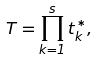<formula> <loc_0><loc_0><loc_500><loc_500>T = \prod _ { k = 1 } ^ { s } t _ { k } ^ { * } ,</formula> 